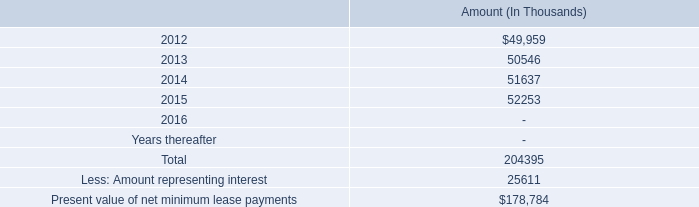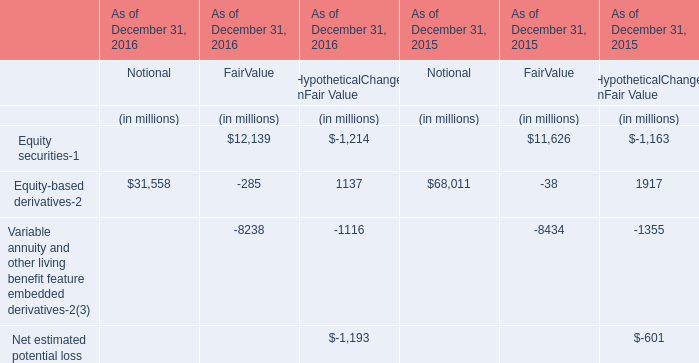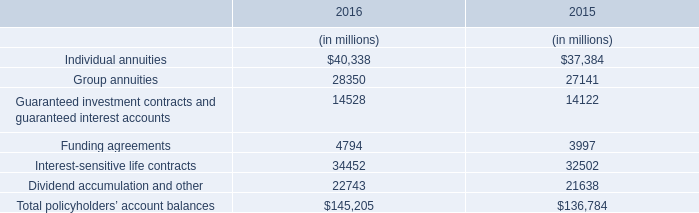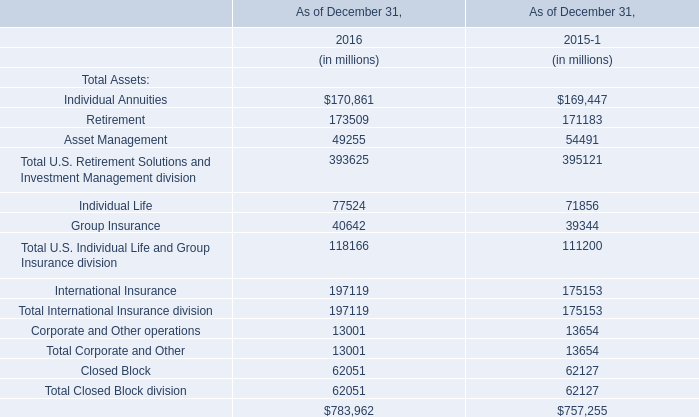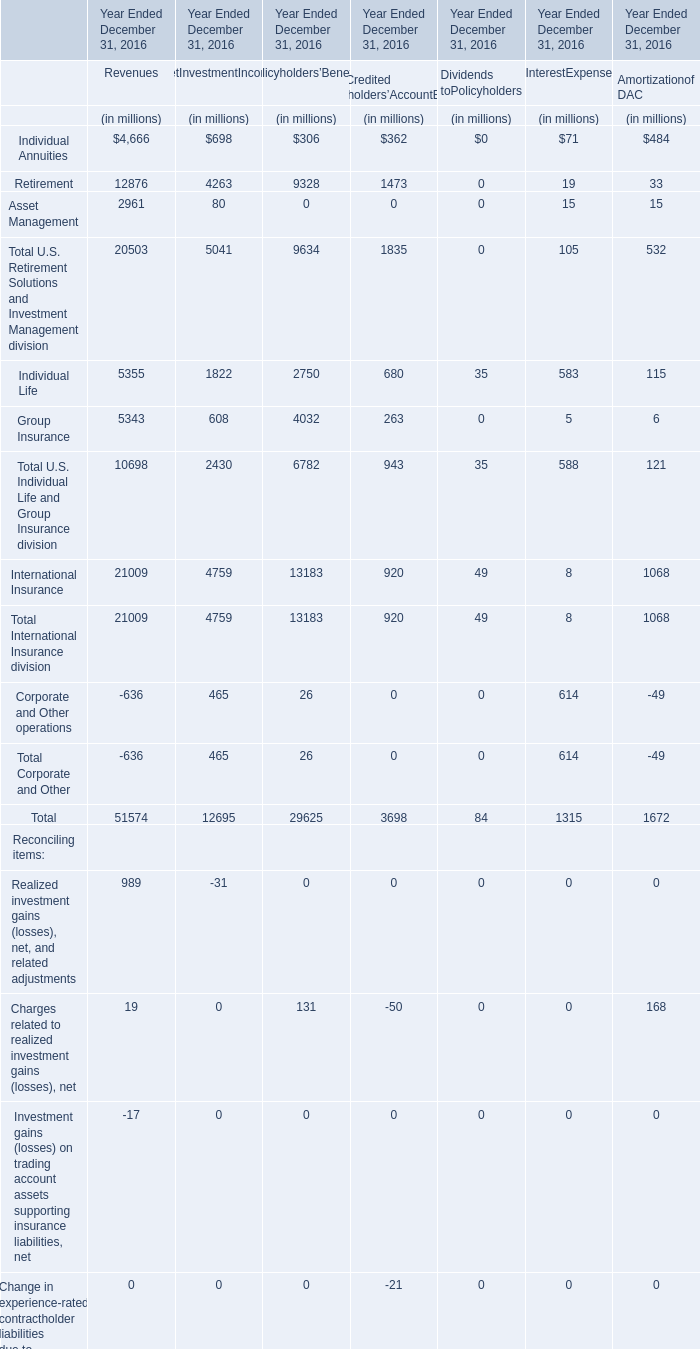As As the chart 3 shows, which year is Total International Insurance division as of December 31 greater than 190000 million? 
Answer: 2016. 